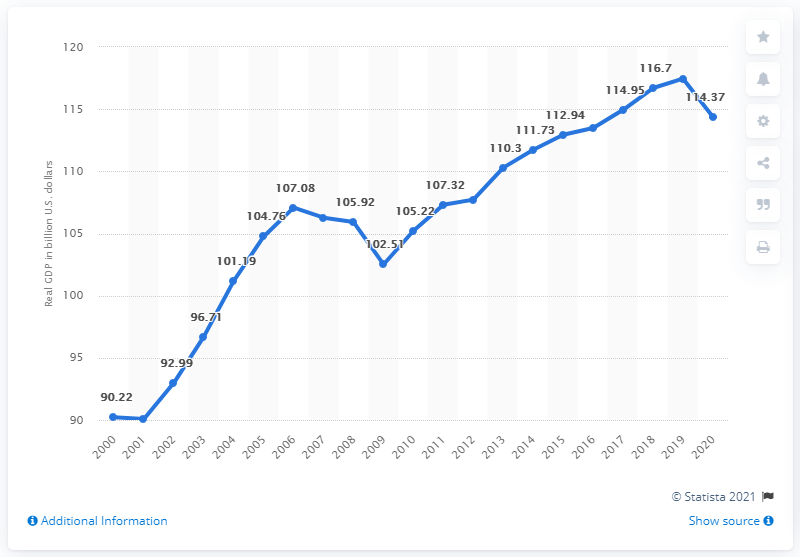Outline some significant characteristics in this image. In 2020, the real Gross Domestic Product (GDP) of Arkansas in dollars was 114.37. 